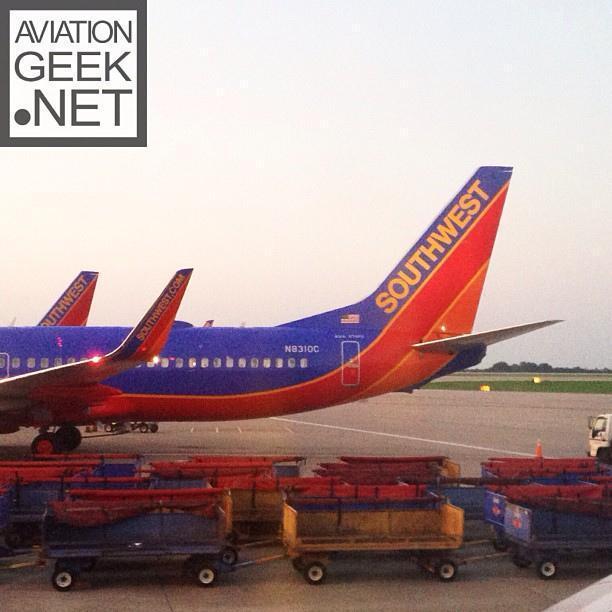How many trucks are visible?
Give a very brief answer. 3. How many cats are on the bench?
Give a very brief answer. 0. 